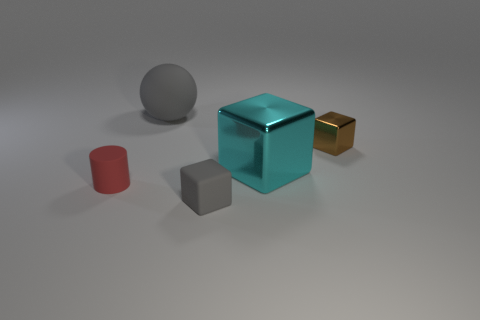Are any green blocks visible?
Provide a short and direct response. No. What size is the rubber thing that is in front of the cyan object and on the right side of the tiny cylinder?
Provide a short and direct response. Small. What is the shape of the small red matte object?
Provide a succinct answer. Cylinder. There is a cube that is behind the big cyan block; are there any big gray matte spheres behind it?
Offer a terse response. Yes. There is a brown object that is the same size as the cylinder; what is it made of?
Provide a succinct answer. Metal. Are there any things that have the same size as the cyan block?
Keep it short and to the point. Yes. What is the block that is to the right of the large cyan block made of?
Make the answer very short. Metal. Do the small cube that is behind the red matte cylinder and the tiny gray thing have the same material?
Provide a short and direct response. No. What shape is the red matte object that is the same size as the brown object?
Provide a succinct answer. Cylinder. How many tiny matte cylinders have the same color as the ball?
Your response must be concise. 0. 